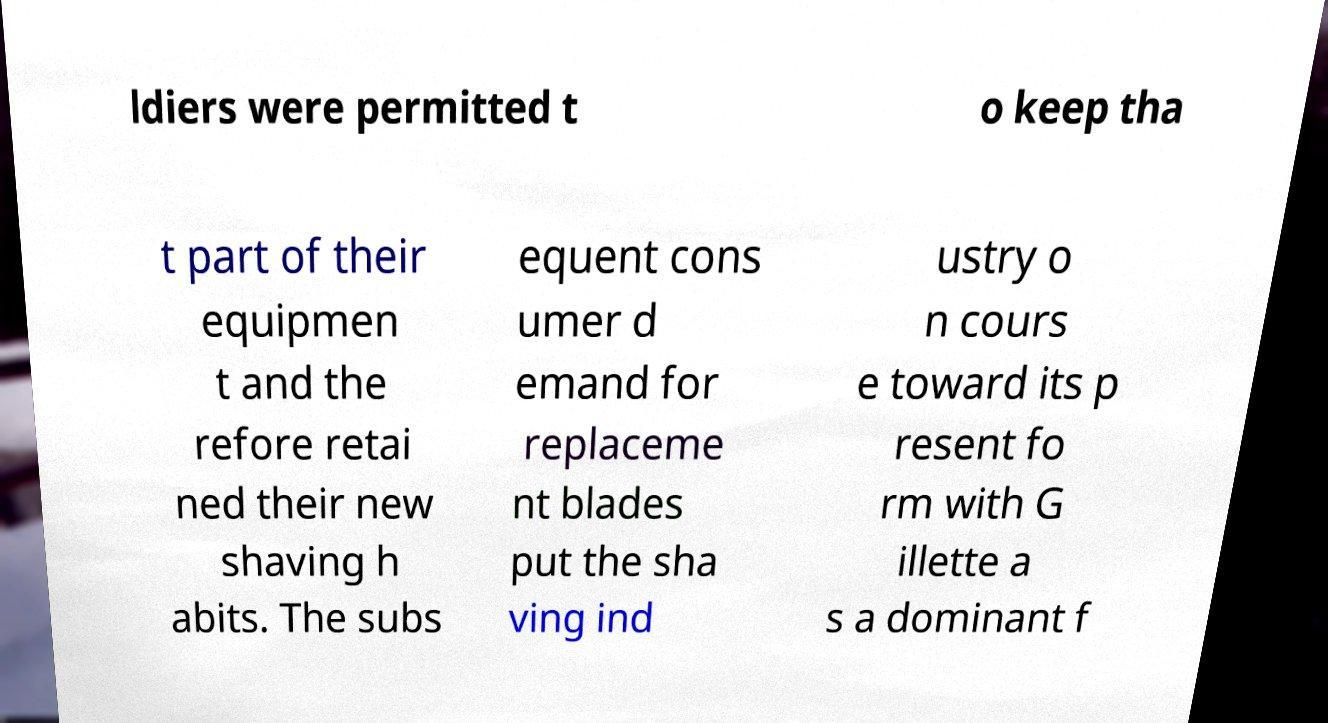Could you assist in decoding the text presented in this image and type it out clearly? ldiers were permitted t o keep tha t part of their equipmen t and the refore retai ned their new shaving h abits. The subs equent cons umer d emand for replaceme nt blades put the sha ving ind ustry o n cours e toward its p resent fo rm with G illette a s a dominant f 